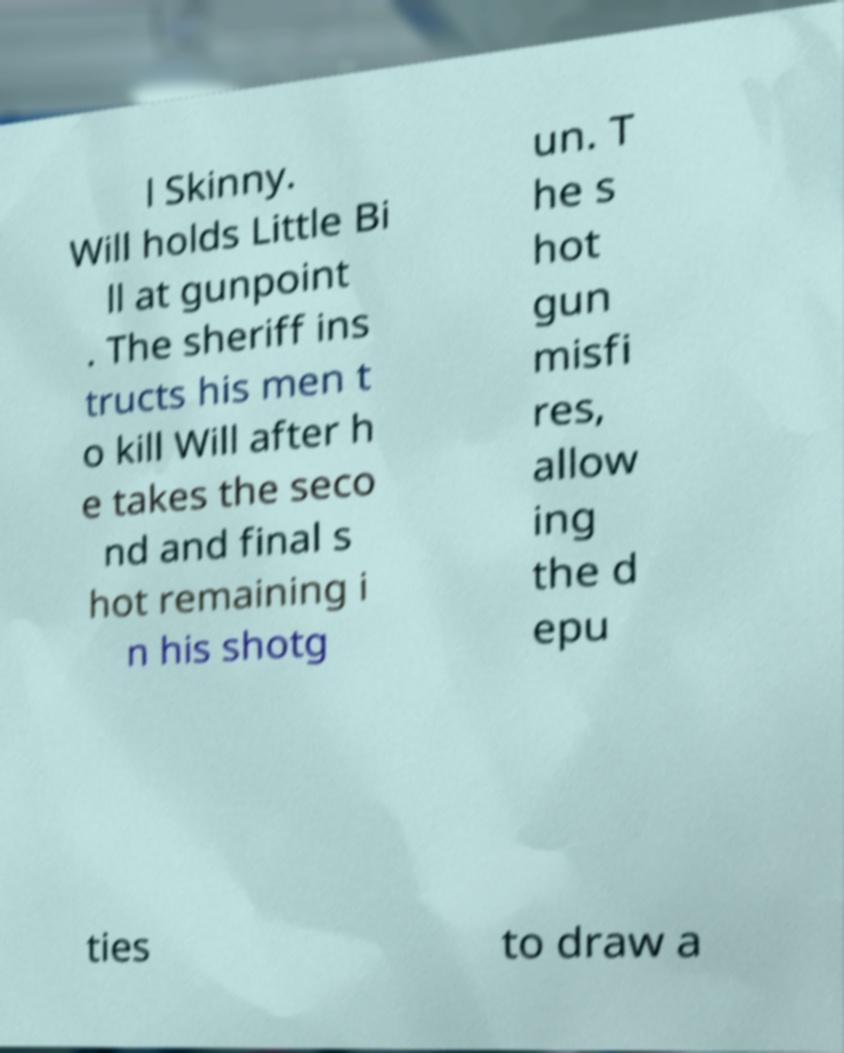For documentation purposes, I need the text within this image transcribed. Could you provide that? l Skinny. Will holds Little Bi ll at gunpoint . The sheriff ins tructs his men t o kill Will after h e takes the seco nd and final s hot remaining i n his shotg un. T he s hot gun misfi res, allow ing the d epu ties to draw a 